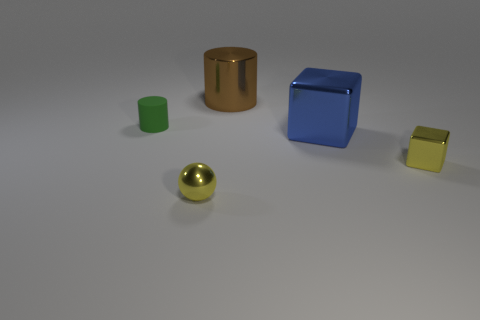Subtract 1 cylinders. How many cylinders are left? 1 Add 5 brown metal cylinders. How many objects exist? 10 Subtract all balls. How many objects are left? 4 Subtract all blue blocks. How many blocks are left? 1 Subtract all brown spheres. Subtract all cyan cubes. How many spheres are left? 1 Subtract all red blocks. How many brown cylinders are left? 1 Add 3 big brown objects. How many big brown objects exist? 4 Subtract 1 brown cylinders. How many objects are left? 4 Subtract all small yellow rubber objects. Subtract all big blue cubes. How many objects are left? 4 Add 1 shiny spheres. How many shiny spheres are left? 2 